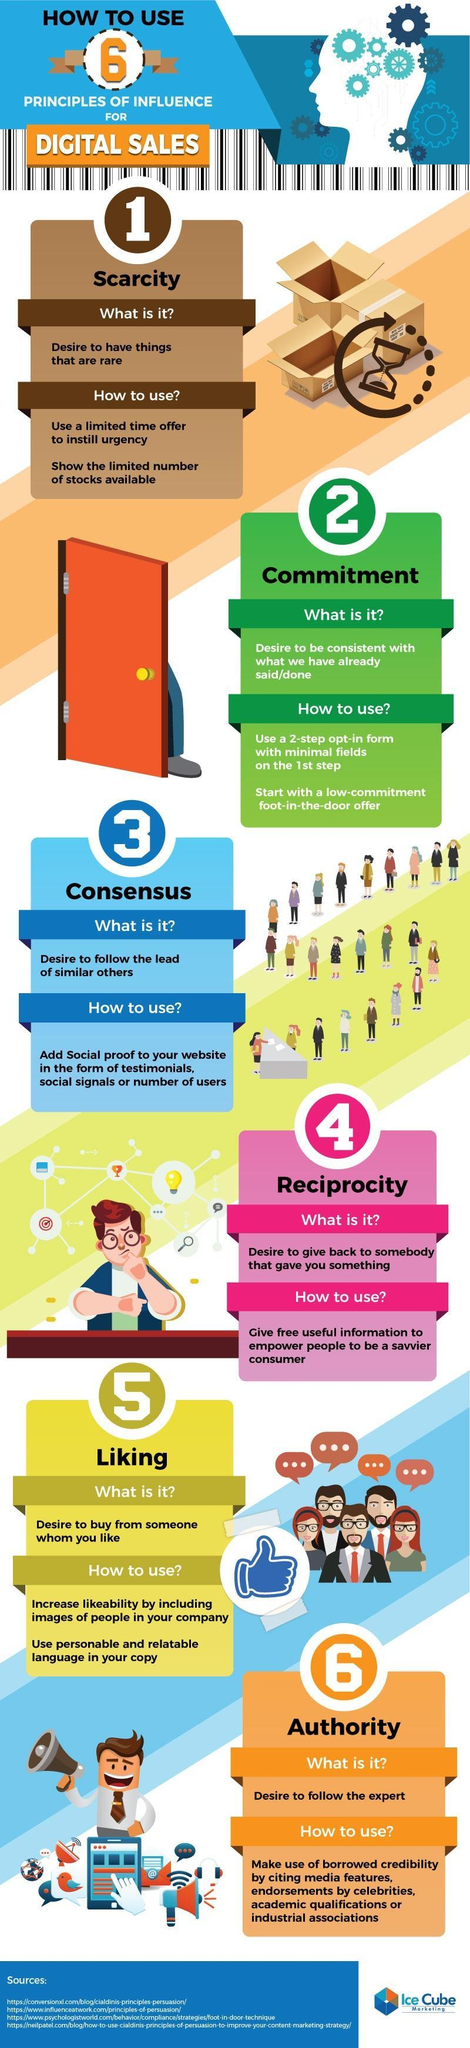Showing a limited number of stocks helps to support which principle?
Answer the question with a short phrase. scarcity 